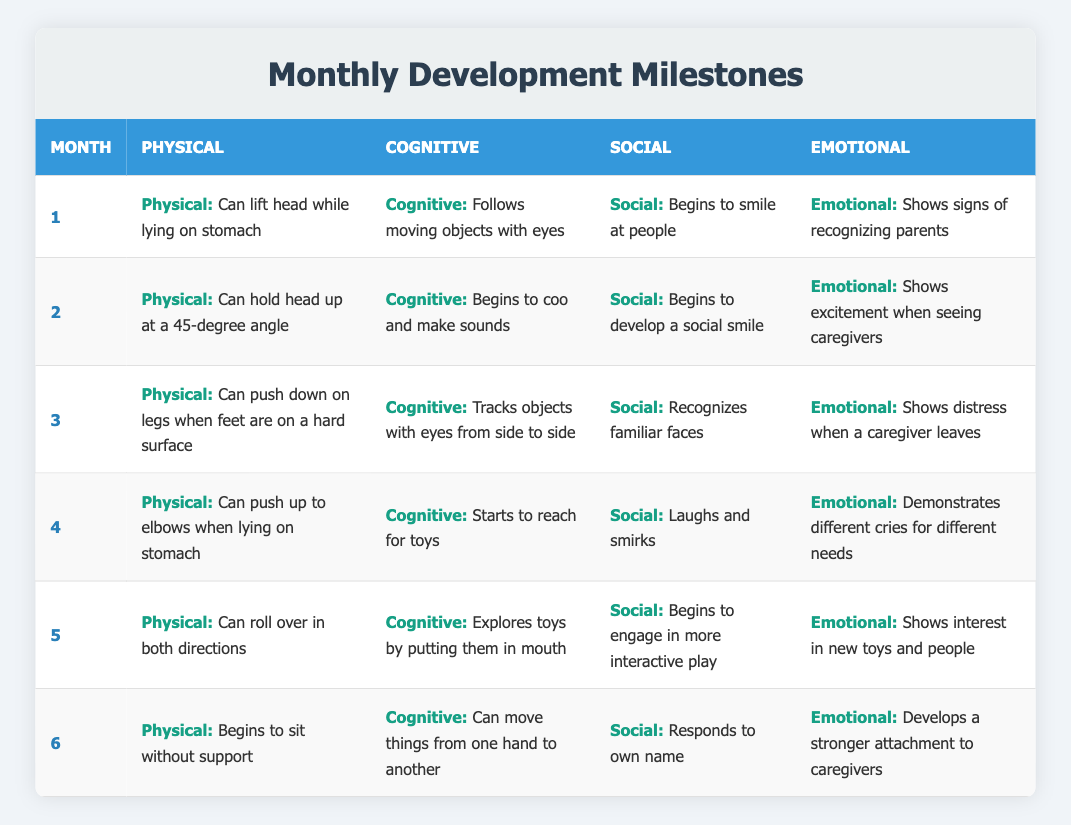What physical milestone is observed at 2 months old? According to the table under the month "2," the physical milestone noted is that the child can hold their head up at a 45-degree angle.
Answer: Can hold head up at a 45-degree angle Which month shows the ability to recognize familiar faces? The table indicates that recognition of familiar faces occurs in the third month.
Answer: 3 Is it true that by month 5, the child shows interest in new toys and people? The information in the table states that at month 5, the child shows interest in new toys and people, confirming the fact.
Answer: Yes What is the average age when a child begins to smile at people? The table shows that the milestone of beginning to smile at people is reached in the first month. Therefore, there is no need for averaging, as the answer reflects a specific age.
Answer: 1 How does the child's social engagement develop from 4 to 5 months? In the fourth month, the child laughs and smirks, indicating social engagement. By the fifth month, they engage in more interactive play. Therefore, the development from month 4 to month 5 reflects an increase in social engagement.
Answer: Increased engagement Which cognitive milestone appears first, "Follows moving objects with eyes" or "Tracks objects with eyes from side to side"? The table indicates that "Follows moving objects with eyes" occurs in month 1, while "Tracks objects with eyes from side to side" occurs in month 3. Thus, "Follows moving objects with eyes" is the earlier milestone.
Answer: Follows moving objects with eyes How many different emotional milestones are noted by 6 months? By checking the table, we find four different emotional milestones listed across the months, with the child developing a stronger attachment to caregivers by 6 months. Count the unique emotional milestones through all evaluated months.
Answer: 4 What are the last two physical milestones listed before 6 months? The fifth month has "Can roll over in both directions" and the fourth month has "Can push up to elbows when lying on stomach." Thus, those are the last two physical milestones noted before 6 months.
Answer: Can roll over in both directions; Can push up to elbows when lying on stomach What changes occur in a child's emotional responses from month 3 to month 4? In month 3, the emotional response reflects distress when a caregiver leaves. By month 4, the child demonstrates different cries for different needs. This signifies a progression in emotional complexity.
Answer: Progression in emotional complexity 